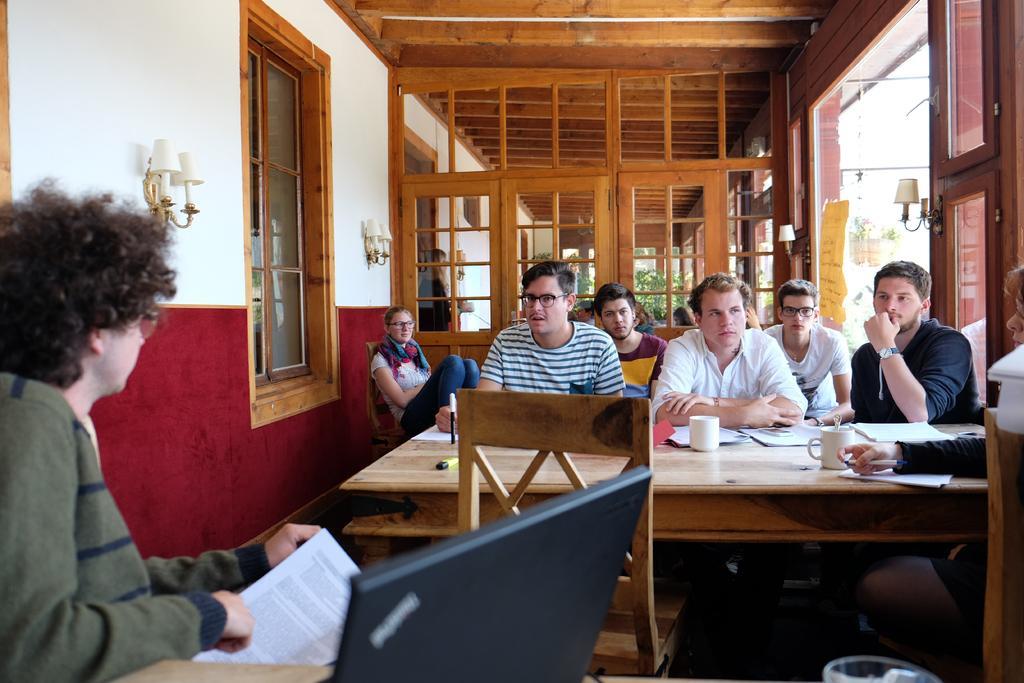Describe this image in one or two sentences. Here we can see that a group of people are sitting on the chair, and in front there is the table and cups and papers on it and some other objects on it, and here is the person sitting holding papers in his hand, and in front there is laptop , and here is the window and here is the wall ,and lamp on it, and here is the door, and a person standing. 